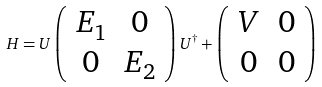<formula> <loc_0><loc_0><loc_500><loc_500>H = U \left ( \begin{array} { c c c } E _ { 1 } & 0 \\ 0 & E _ { 2 } \end{array} \right ) U ^ { \dagger } + \left ( \begin{array} { c c c } V & 0 \\ 0 & 0 \end{array} \right )</formula> 